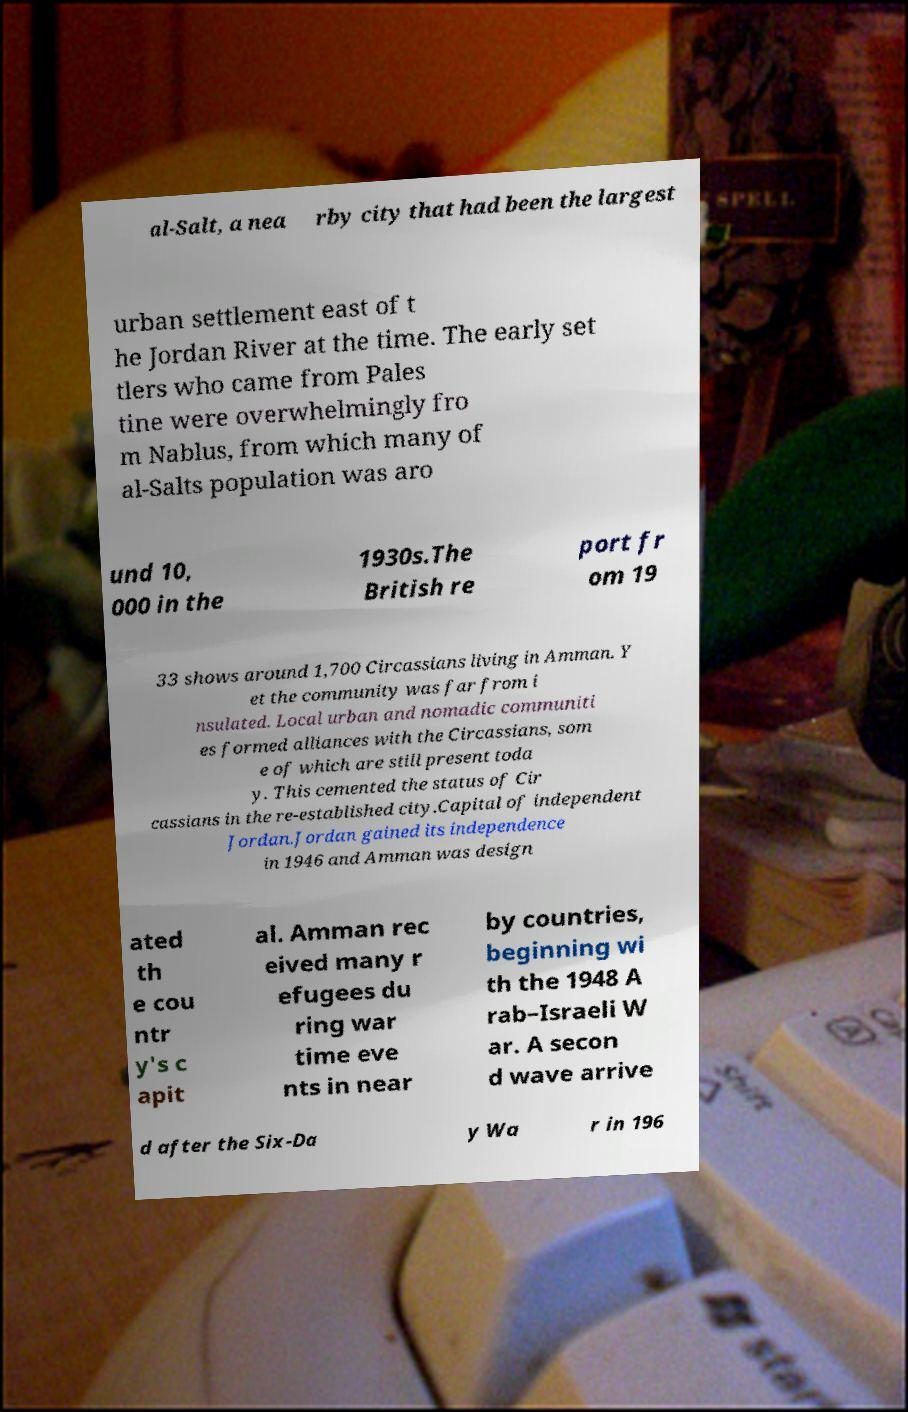Could you extract and type out the text from this image? al-Salt, a nea rby city that had been the largest urban settlement east of t he Jordan River at the time. The early set tlers who came from Pales tine were overwhelmingly fro m Nablus, from which many of al-Salts population was aro und 10, 000 in the 1930s.The British re port fr om 19 33 shows around 1,700 Circassians living in Amman. Y et the community was far from i nsulated. Local urban and nomadic communiti es formed alliances with the Circassians, som e of which are still present toda y. This cemented the status of Cir cassians in the re-established city.Capital of independent Jordan.Jordan gained its independence in 1946 and Amman was design ated th e cou ntr y's c apit al. Amman rec eived many r efugees du ring war time eve nts in near by countries, beginning wi th the 1948 A rab–Israeli W ar. A secon d wave arrive d after the Six-Da y Wa r in 196 